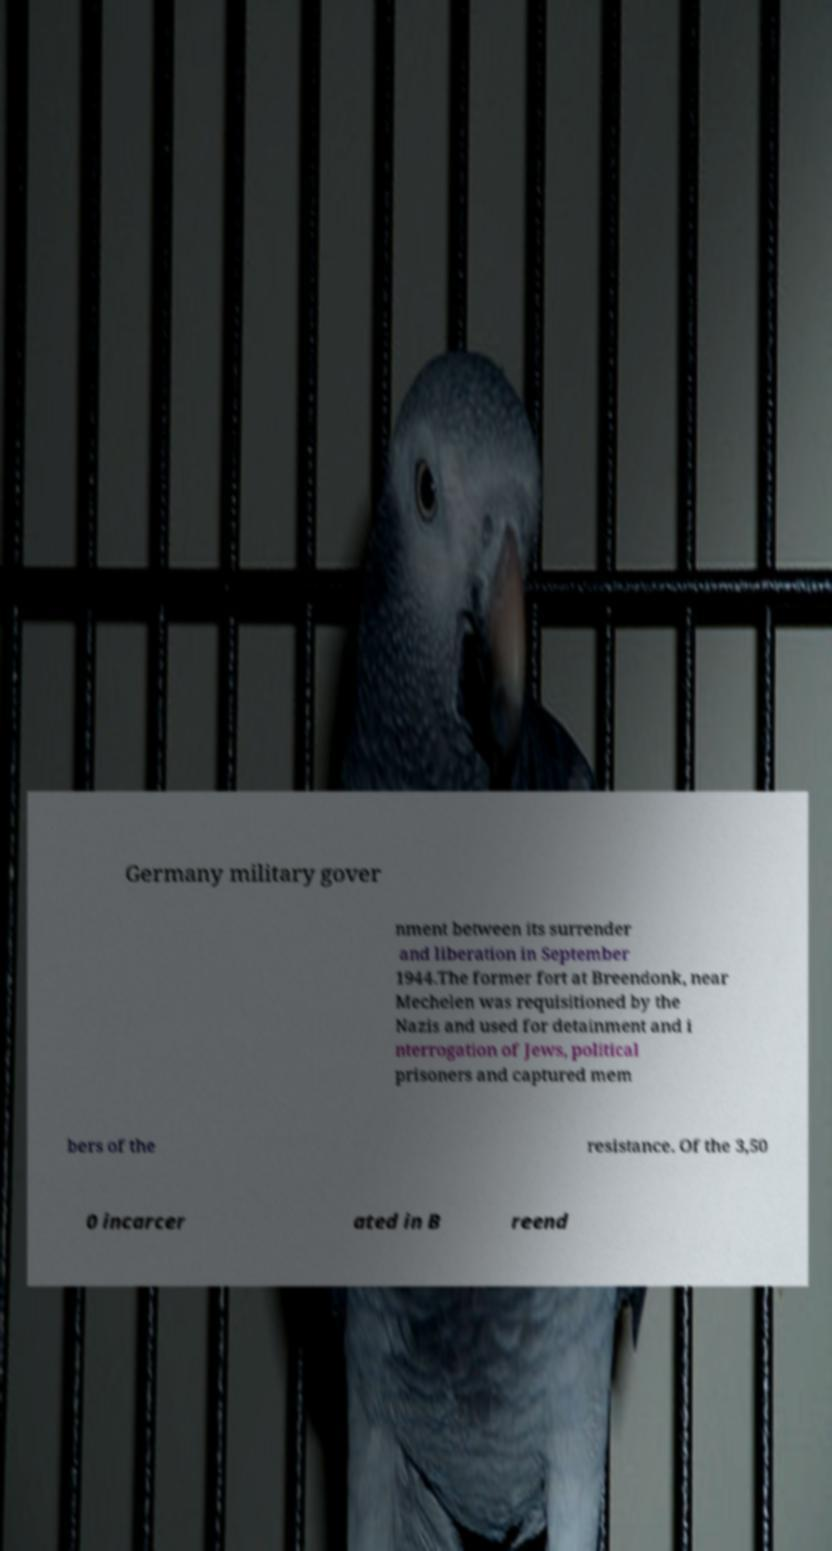Can you read and provide the text displayed in the image?This photo seems to have some interesting text. Can you extract and type it out for me? Germany military gover nment between its surrender and liberation in September 1944.The former fort at Breendonk, near Mechelen was requisitioned by the Nazis and used for detainment and i nterrogation of Jews, political prisoners and captured mem bers of the resistance. Of the 3,50 0 incarcer ated in B reend 